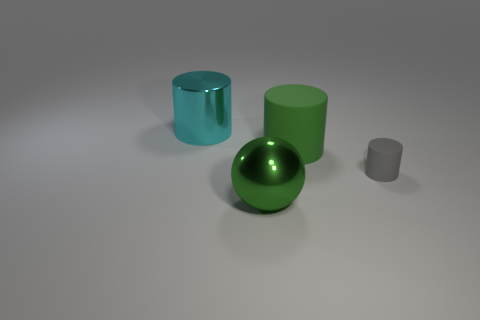How many other objects are the same color as the metallic sphere?
Provide a short and direct response. 1. Is the large cylinder that is right of the big cyan cylinder made of the same material as the gray object that is on the right side of the large green metallic sphere?
Ensure brevity in your answer.  Yes. What size is the matte cylinder that is right of the green matte object?
Your response must be concise. Small. There is a large cyan object that is the same shape as the gray object; what is its material?
Offer a very short reply. Metal. Are there any other things that have the same size as the gray cylinder?
Offer a very short reply. No. The metallic object that is to the left of the shiny ball has what shape?
Your answer should be compact. Cylinder. How many large green shiny things have the same shape as the gray object?
Offer a terse response. 0. Is the number of green cylinders behind the tiny gray matte object the same as the number of metal things on the right side of the large cyan cylinder?
Provide a short and direct response. Yes. Is there a big green thing that has the same material as the cyan cylinder?
Your response must be concise. Yes. Is the large green sphere made of the same material as the big cyan thing?
Make the answer very short. Yes. 